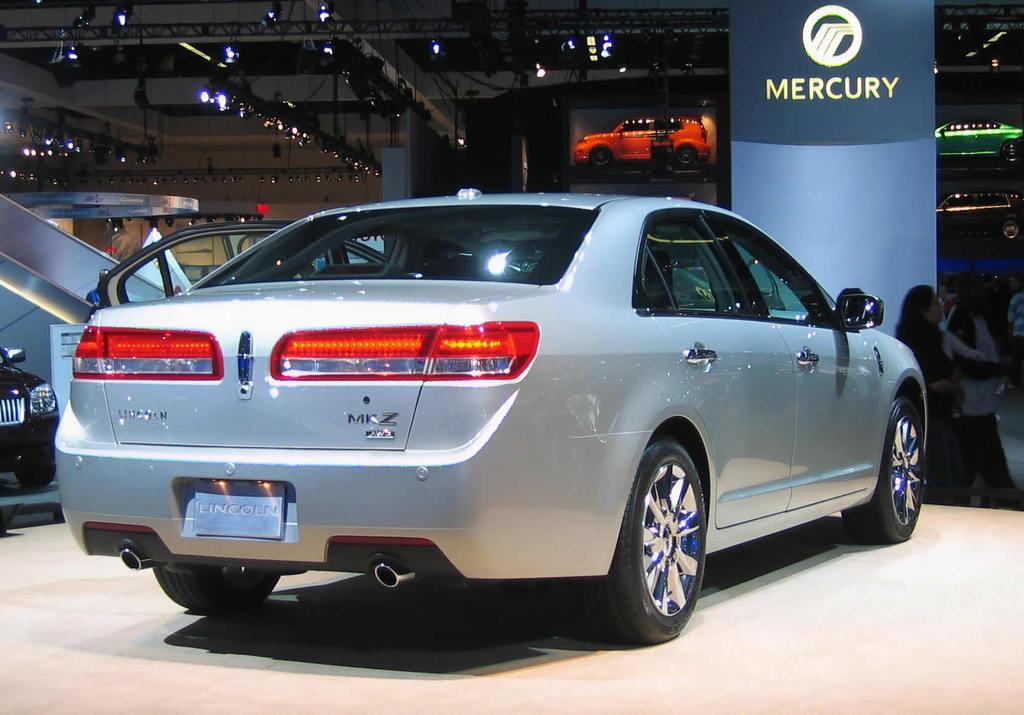Describe this image in one or two sentences. In the foreground of this image, there is a car on the stage. In the background, there is a signage, few persons on the floor and other car on the left and also there are few cars, lights and ceiling in the background. 